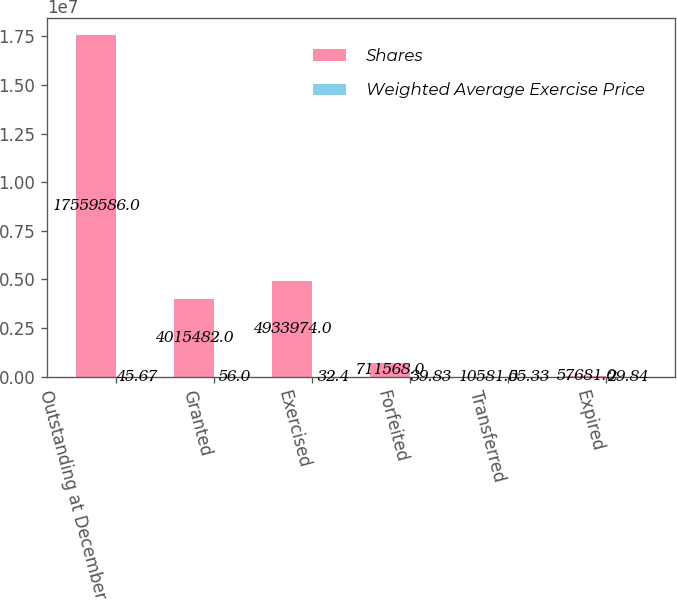Convert chart to OTSL. <chart><loc_0><loc_0><loc_500><loc_500><stacked_bar_chart><ecel><fcel>Outstanding at December 31<fcel>Granted<fcel>Exercised<fcel>Forfeited<fcel>Transferred<fcel>Expired<nl><fcel>Shares<fcel>1.75596e+07<fcel>4.01548e+06<fcel>4.93397e+06<fcel>711568<fcel>10581<fcel>57681<nl><fcel>Weighted Average Exercise Price<fcel>45.67<fcel>56<fcel>32.4<fcel>39.83<fcel>55.33<fcel>29.84<nl></chart> 